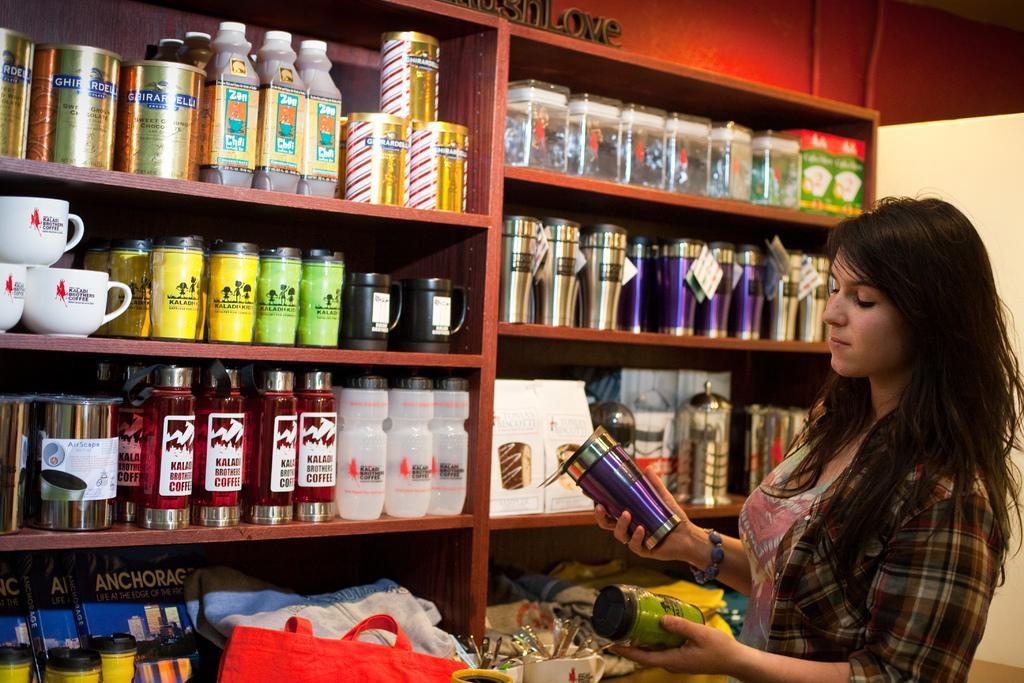Please provide a concise description of this image. In this image I see a woman who is holding the can and a jar. In the background I see rack full of jars, bottles, cups and few things. 